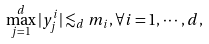Convert formula to latex. <formula><loc_0><loc_0><loc_500><loc_500>\max _ { j = 1 } ^ { d } | y ^ { i } _ { j } | \lesssim _ { d } m _ { i } , \forall i = 1 , \cdots , d ,</formula> 